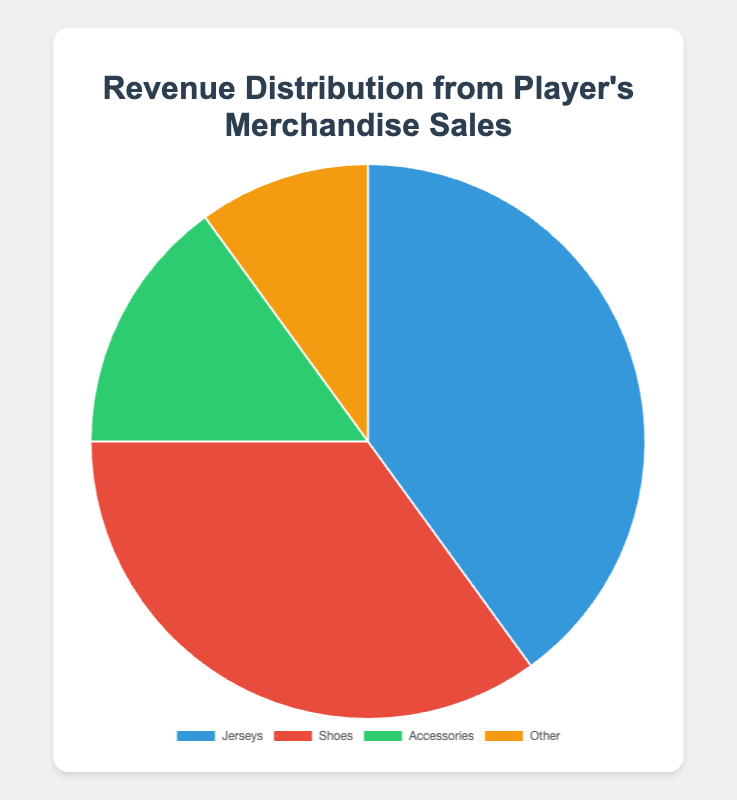Which category contributes the most to the player's merchandise sales? By glancing at the pie chart, the segment with the largest proportion represents the category that contributes the most. In this case, Jerseys have the largest segment.
Answer: Jerseys What is the combined percentage of Shoes and Accessories sales? Summing the individual percentages of Shoes (35%) and Accessories (15%) gives the combined percentage. 35 + 15 = 50
Answer: 50% Which category contributes less to the player's merchandise sales, Accessories or Other? Comparing the two segments, Accessories (15%) and Other (10%), the Other category has a smaller percentage.
Answer: Other How much more is the revenue from Jerseys compared to Other? Calculating the difference between the percentages of Jerseys (40%) and Other (10%), we get 40 - 10 = 30
Answer: 30% If Accessories and Other categories were combined into a single category, how would their total percentage compare to Shoes? Summing the percentages of Accessories (15%) and Other (10%), we get 15 + 10 = 25%. This total is then compared to Shoes (35%). 25% is less than 35%.
Answer: Shoes Which two categories together contribute a majority of the player's merchandise sales? Summing various pairs, the pairs Jerseys (40%) and Shoes (35%) together contribute 40 + 35 = 75%, which is a majority.
Answer: Jerseys and Shoes What would be the new percentage for Jerseys if its sales increased by 10%? Adding 10% to the current percentage of Jerseys (40%), we get 40 + 10 = 50%.
Answer: 50% Among the four categories, which one contributes the least visually and what is its color in the pie chart? The smallest segment in the pie chart is for Other, with a percentage of 10%, and it is colored yellow.
Answer: Other, yellow 